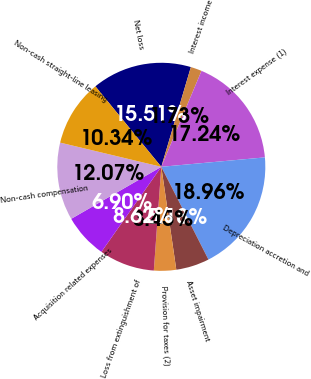Convert chart. <chart><loc_0><loc_0><loc_500><loc_500><pie_chart><fcel>Net loss<fcel>Interest income<fcel>Interest expense (1)<fcel>Depreciation accretion and<fcel>Asset impairment<fcel>Provision for taxes (2)<fcel>Loss from extinguishment of<fcel>Acquisition related expenses<fcel>Non-cash compensation<fcel>Non-cash straight-line leasing<nl><fcel>15.51%<fcel>1.73%<fcel>17.24%<fcel>18.96%<fcel>5.18%<fcel>3.45%<fcel>8.62%<fcel>6.9%<fcel>12.07%<fcel>10.34%<nl></chart> 